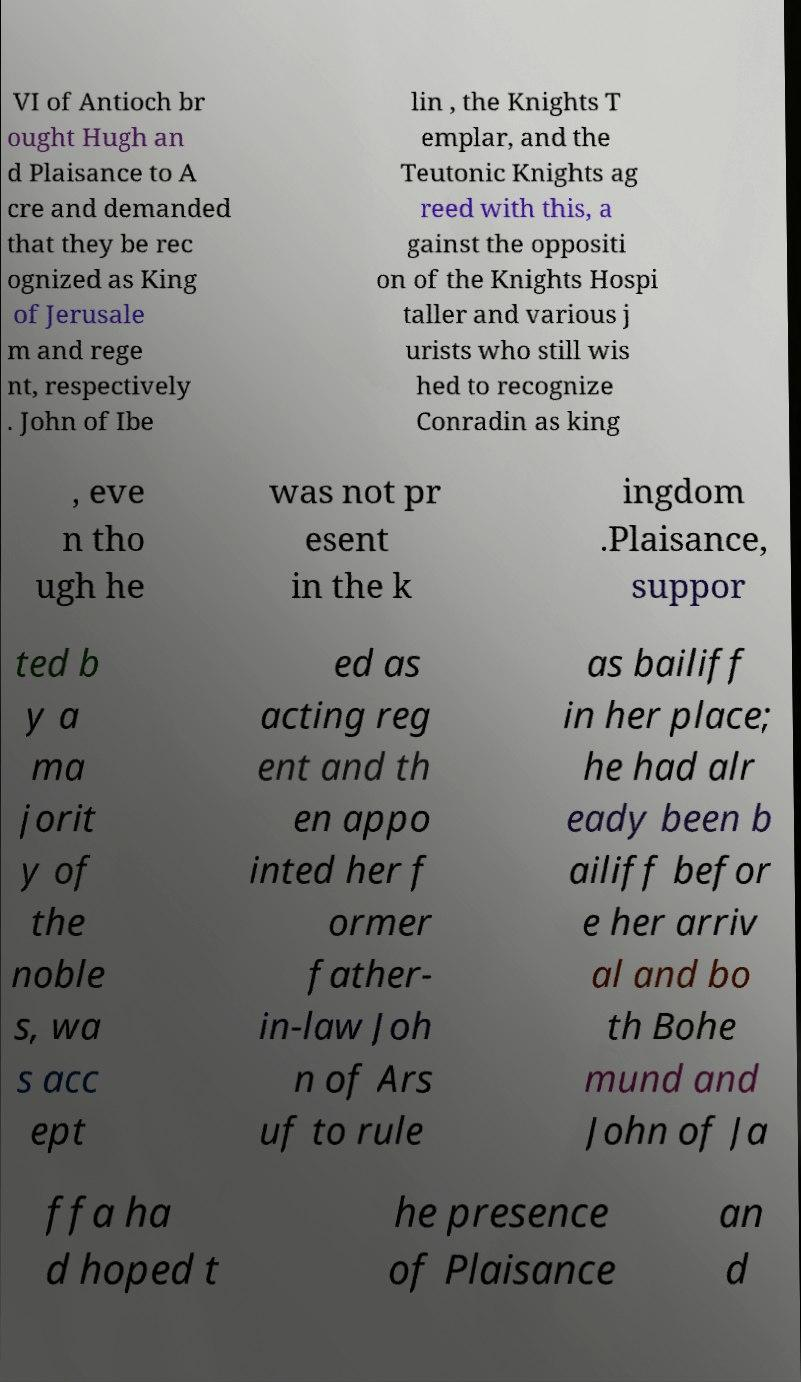Can you accurately transcribe the text from the provided image for me? VI of Antioch br ought Hugh an d Plaisance to A cre and demanded that they be rec ognized as King of Jerusale m and rege nt, respectively . John of Ibe lin , the Knights T emplar, and the Teutonic Knights ag reed with this, a gainst the oppositi on of the Knights Hospi taller and various j urists who still wis hed to recognize Conradin as king , eve n tho ugh he was not pr esent in the k ingdom .Plaisance, suppor ted b y a ma jorit y of the noble s, wa s acc ept ed as acting reg ent and th en appo inted her f ormer father- in-law Joh n of Ars uf to rule as bailiff in her place; he had alr eady been b ailiff befor e her arriv al and bo th Bohe mund and John of Ja ffa ha d hoped t he presence of Plaisance an d 